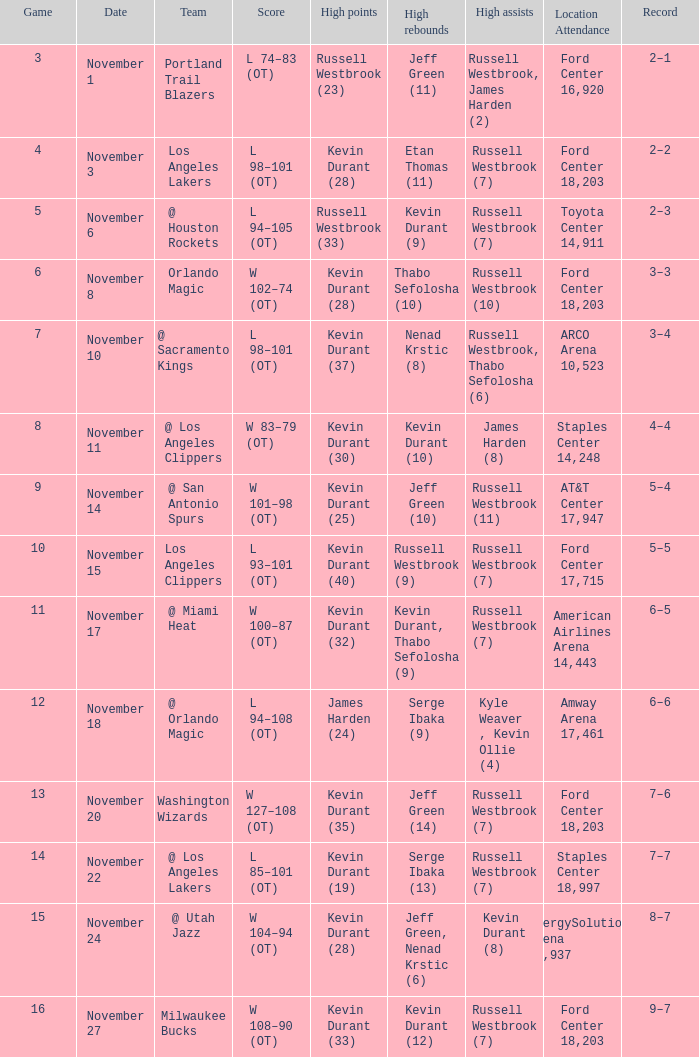In which venue did the game featuring kevin durant (25) with the maximum points take place? AT&T Center 17,947. 